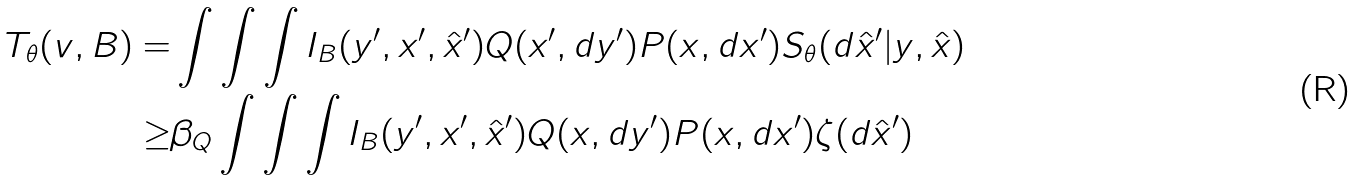Convert formula to latex. <formula><loc_0><loc_0><loc_500><loc_500>T _ { \theta } ( v , B ) = & \int \int \int I _ { B } ( y ^ { \prime } , x ^ { \prime } , \hat { x } ^ { \prime } ) Q ( x ^ { \prime } , d y ^ { \prime } ) P ( x , d x ^ { \prime } ) S _ { \theta } ( d \hat { x } ^ { \prime } | y , \hat { x } ) \\ \geq & \beta _ { Q } \int \int \int I _ { B } ( y ^ { \prime } , x ^ { \prime } , \hat { x } ^ { \prime } ) Q ( x , d y ^ { \prime } ) P ( x , d x ^ { \prime } ) \zeta ( d \hat { x } ^ { \prime } )</formula> 